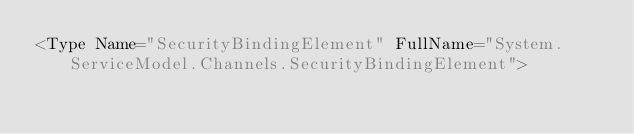Convert code to text. <code><loc_0><loc_0><loc_500><loc_500><_XML_><Type Name="SecurityBindingElement" FullName="System.ServiceModel.Channels.SecurityBindingElement"></code> 